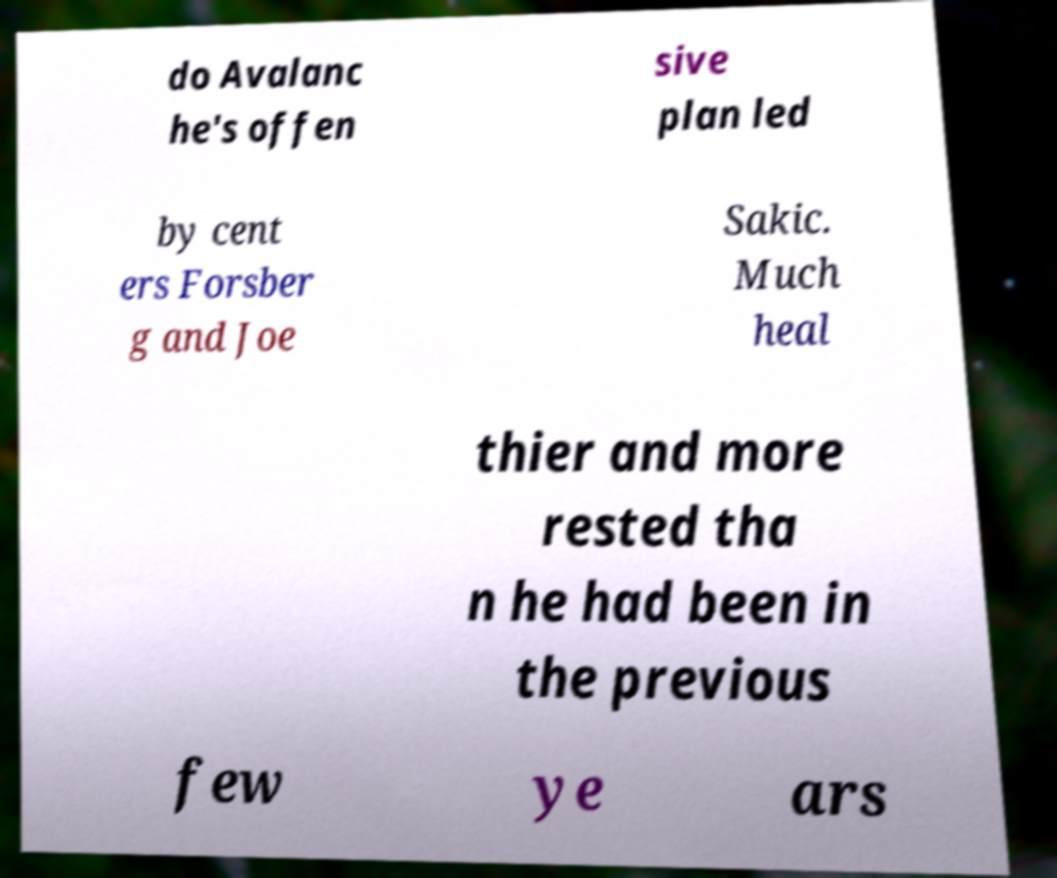I need the written content from this picture converted into text. Can you do that? do Avalanc he's offen sive plan led by cent ers Forsber g and Joe Sakic. Much heal thier and more rested tha n he had been in the previous few ye ars 